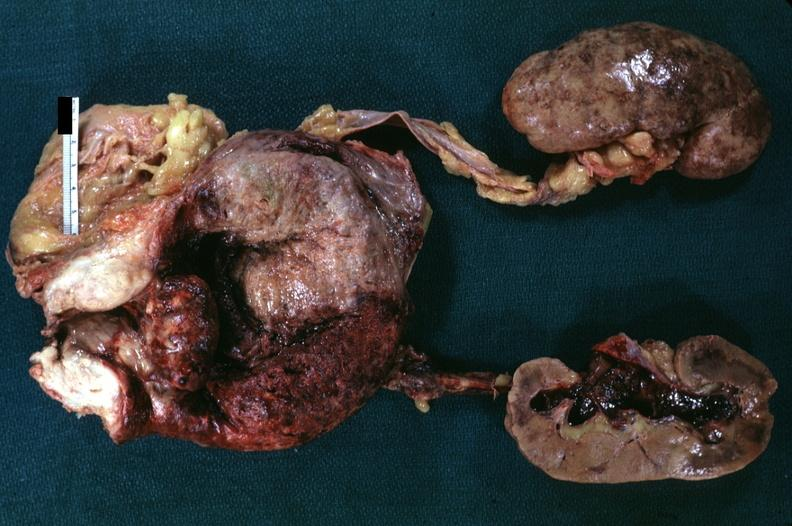what do median lobe hyperplasia with marked cystitis and bladder hypertrophy ureter appear?
Answer the question using a single word or phrase. Normal focal hemorrhages in kidneys hemorrhagic pyelitis indicates pyelonephritis carcinoma in prostate is diagnosis but can not 